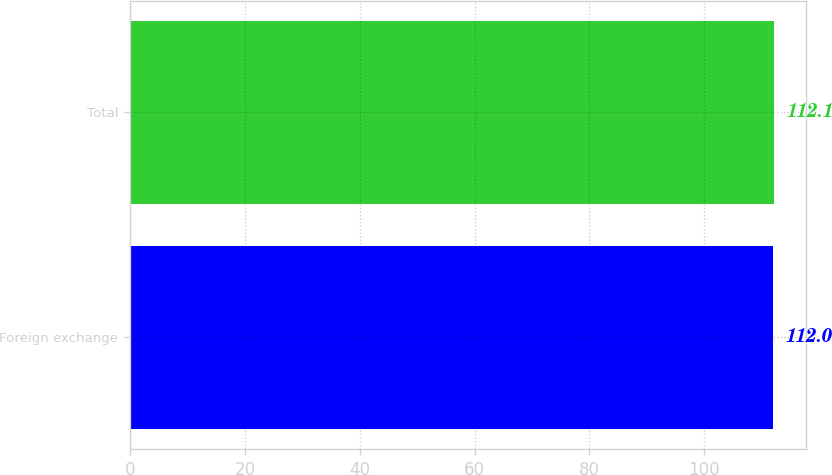Convert chart to OTSL. <chart><loc_0><loc_0><loc_500><loc_500><bar_chart><fcel>Foreign exchange<fcel>Total<nl><fcel>112<fcel>112.1<nl></chart> 